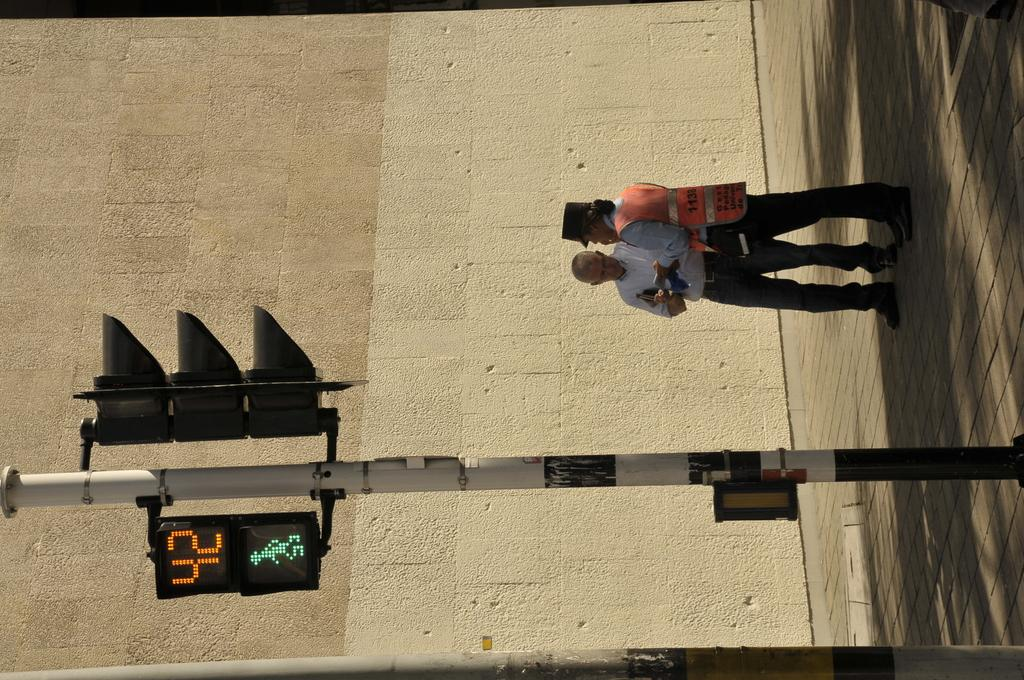<image>
Render a clear and concise summary of the photo. A crosswalk light with 42 seconds remaining on it. 